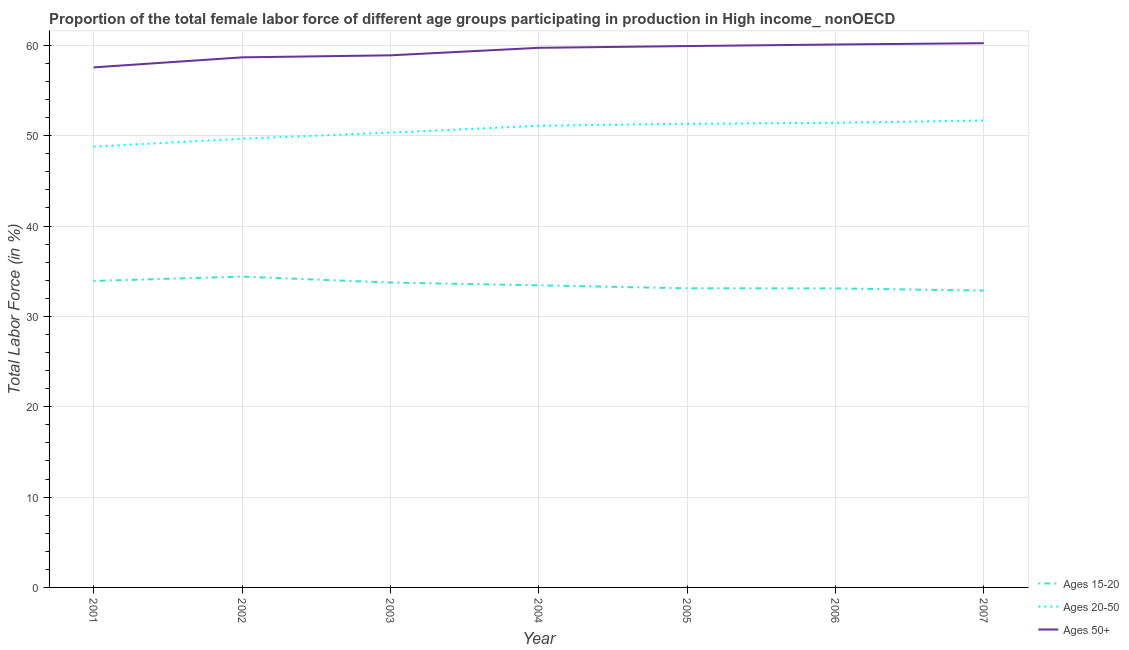How many different coloured lines are there?
Your answer should be compact. 3. Is the number of lines equal to the number of legend labels?
Your response must be concise. Yes. What is the percentage of female labor force within the age group 20-50 in 2002?
Ensure brevity in your answer.  49.66. Across all years, what is the maximum percentage of female labor force within the age group 20-50?
Your answer should be very brief. 51.68. Across all years, what is the minimum percentage of female labor force within the age group 15-20?
Offer a very short reply. 32.85. In which year was the percentage of female labor force within the age group 20-50 minimum?
Keep it short and to the point. 2001. What is the total percentage of female labor force above age 50 in the graph?
Offer a terse response. 415.1. What is the difference between the percentage of female labor force above age 50 in 2002 and that in 2006?
Ensure brevity in your answer.  -1.42. What is the difference between the percentage of female labor force within the age group 20-50 in 2002 and the percentage of female labor force within the age group 15-20 in 2003?
Keep it short and to the point. 15.92. What is the average percentage of female labor force within the age group 20-50 per year?
Your answer should be compact. 50.62. In the year 2001, what is the difference between the percentage of female labor force within the age group 15-20 and percentage of female labor force above age 50?
Make the answer very short. -23.64. What is the ratio of the percentage of female labor force within the age group 20-50 in 2002 to that in 2003?
Offer a terse response. 0.99. Is the percentage of female labor force above age 50 in 2006 less than that in 2007?
Offer a terse response. Yes. Is the difference between the percentage of female labor force within the age group 15-20 in 2002 and 2006 greater than the difference between the percentage of female labor force within the age group 20-50 in 2002 and 2006?
Provide a short and direct response. Yes. What is the difference between the highest and the second highest percentage of female labor force within the age group 20-50?
Your answer should be very brief. 0.26. What is the difference between the highest and the lowest percentage of female labor force within the age group 15-20?
Your answer should be compact. 1.55. Is the sum of the percentage of female labor force above age 50 in 2003 and 2005 greater than the maximum percentage of female labor force within the age group 15-20 across all years?
Offer a very short reply. Yes. Is it the case that in every year, the sum of the percentage of female labor force within the age group 15-20 and percentage of female labor force within the age group 20-50 is greater than the percentage of female labor force above age 50?
Your response must be concise. Yes. Is the percentage of female labor force within the age group 15-20 strictly greater than the percentage of female labor force within the age group 20-50 over the years?
Your answer should be very brief. No. How many lines are there?
Ensure brevity in your answer.  3. How many years are there in the graph?
Keep it short and to the point. 7. What is the difference between two consecutive major ticks on the Y-axis?
Your answer should be very brief. 10. Are the values on the major ticks of Y-axis written in scientific E-notation?
Your response must be concise. No. Does the graph contain grids?
Ensure brevity in your answer.  Yes. Where does the legend appear in the graph?
Provide a succinct answer. Bottom right. How many legend labels are there?
Your response must be concise. 3. What is the title of the graph?
Offer a very short reply. Proportion of the total female labor force of different age groups participating in production in High income_ nonOECD. Does "Domestic economy" appear as one of the legend labels in the graph?
Give a very brief answer. No. What is the label or title of the Y-axis?
Keep it short and to the point. Total Labor Force (in %). What is the Total Labor Force (in %) in Ages 15-20 in 2001?
Your answer should be very brief. 33.92. What is the Total Labor Force (in %) of Ages 20-50 in 2001?
Give a very brief answer. 48.79. What is the Total Labor Force (in %) in Ages 50+ in 2001?
Offer a terse response. 57.56. What is the Total Labor Force (in %) in Ages 15-20 in 2002?
Ensure brevity in your answer.  34.4. What is the Total Labor Force (in %) in Ages 20-50 in 2002?
Provide a short and direct response. 49.66. What is the Total Labor Force (in %) in Ages 50+ in 2002?
Ensure brevity in your answer.  58.67. What is the Total Labor Force (in %) of Ages 15-20 in 2003?
Give a very brief answer. 33.74. What is the Total Labor Force (in %) of Ages 20-50 in 2003?
Your response must be concise. 50.34. What is the Total Labor Force (in %) of Ages 50+ in 2003?
Your response must be concise. 58.89. What is the Total Labor Force (in %) of Ages 15-20 in 2004?
Give a very brief answer. 33.44. What is the Total Labor Force (in %) of Ages 20-50 in 2004?
Keep it short and to the point. 51.1. What is the Total Labor Force (in %) in Ages 50+ in 2004?
Make the answer very short. 59.72. What is the Total Labor Force (in %) of Ages 15-20 in 2005?
Provide a short and direct response. 33.11. What is the Total Labor Force (in %) of Ages 20-50 in 2005?
Provide a short and direct response. 51.32. What is the Total Labor Force (in %) of Ages 50+ in 2005?
Provide a succinct answer. 59.92. What is the Total Labor Force (in %) of Ages 15-20 in 2006?
Keep it short and to the point. 33.1. What is the Total Labor Force (in %) of Ages 20-50 in 2006?
Make the answer very short. 51.42. What is the Total Labor Force (in %) in Ages 50+ in 2006?
Your answer should be very brief. 60.09. What is the Total Labor Force (in %) of Ages 15-20 in 2007?
Make the answer very short. 32.85. What is the Total Labor Force (in %) of Ages 20-50 in 2007?
Provide a succinct answer. 51.68. What is the Total Labor Force (in %) in Ages 50+ in 2007?
Your response must be concise. 60.24. Across all years, what is the maximum Total Labor Force (in %) of Ages 15-20?
Offer a very short reply. 34.4. Across all years, what is the maximum Total Labor Force (in %) in Ages 20-50?
Provide a succinct answer. 51.68. Across all years, what is the maximum Total Labor Force (in %) of Ages 50+?
Give a very brief answer. 60.24. Across all years, what is the minimum Total Labor Force (in %) of Ages 15-20?
Offer a very short reply. 32.85. Across all years, what is the minimum Total Labor Force (in %) of Ages 20-50?
Give a very brief answer. 48.79. Across all years, what is the minimum Total Labor Force (in %) of Ages 50+?
Your answer should be compact. 57.56. What is the total Total Labor Force (in %) in Ages 15-20 in the graph?
Provide a short and direct response. 234.56. What is the total Total Labor Force (in %) in Ages 20-50 in the graph?
Provide a short and direct response. 354.31. What is the total Total Labor Force (in %) of Ages 50+ in the graph?
Make the answer very short. 415.1. What is the difference between the Total Labor Force (in %) in Ages 15-20 in 2001 and that in 2002?
Your response must be concise. -0.48. What is the difference between the Total Labor Force (in %) in Ages 20-50 in 2001 and that in 2002?
Provide a succinct answer. -0.87. What is the difference between the Total Labor Force (in %) in Ages 50+ in 2001 and that in 2002?
Offer a very short reply. -1.11. What is the difference between the Total Labor Force (in %) of Ages 15-20 in 2001 and that in 2003?
Make the answer very short. 0.18. What is the difference between the Total Labor Force (in %) of Ages 20-50 in 2001 and that in 2003?
Your answer should be very brief. -1.55. What is the difference between the Total Labor Force (in %) of Ages 50+ in 2001 and that in 2003?
Your answer should be compact. -1.33. What is the difference between the Total Labor Force (in %) in Ages 15-20 in 2001 and that in 2004?
Your answer should be compact. 0.48. What is the difference between the Total Labor Force (in %) of Ages 20-50 in 2001 and that in 2004?
Your answer should be compact. -2.31. What is the difference between the Total Labor Force (in %) of Ages 50+ in 2001 and that in 2004?
Your answer should be compact. -2.16. What is the difference between the Total Labor Force (in %) in Ages 15-20 in 2001 and that in 2005?
Ensure brevity in your answer.  0.81. What is the difference between the Total Labor Force (in %) in Ages 20-50 in 2001 and that in 2005?
Offer a very short reply. -2.53. What is the difference between the Total Labor Force (in %) in Ages 50+ in 2001 and that in 2005?
Offer a very short reply. -2.36. What is the difference between the Total Labor Force (in %) in Ages 15-20 in 2001 and that in 2006?
Your answer should be compact. 0.82. What is the difference between the Total Labor Force (in %) in Ages 20-50 in 2001 and that in 2006?
Ensure brevity in your answer.  -2.63. What is the difference between the Total Labor Force (in %) of Ages 50+ in 2001 and that in 2006?
Offer a terse response. -2.53. What is the difference between the Total Labor Force (in %) in Ages 15-20 in 2001 and that in 2007?
Give a very brief answer. 1.07. What is the difference between the Total Labor Force (in %) of Ages 20-50 in 2001 and that in 2007?
Ensure brevity in your answer.  -2.89. What is the difference between the Total Labor Force (in %) in Ages 50+ in 2001 and that in 2007?
Offer a terse response. -2.68. What is the difference between the Total Labor Force (in %) in Ages 15-20 in 2002 and that in 2003?
Provide a succinct answer. 0.66. What is the difference between the Total Labor Force (in %) in Ages 20-50 in 2002 and that in 2003?
Offer a very short reply. -0.67. What is the difference between the Total Labor Force (in %) in Ages 50+ in 2002 and that in 2003?
Keep it short and to the point. -0.22. What is the difference between the Total Labor Force (in %) in Ages 15-20 in 2002 and that in 2004?
Provide a succinct answer. 0.96. What is the difference between the Total Labor Force (in %) of Ages 20-50 in 2002 and that in 2004?
Your response must be concise. -1.43. What is the difference between the Total Labor Force (in %) of Ages 50+ in 2002 and that in 2004?
Keep it short and to the point. -1.05. What is the difference between the Total Labor Force (in %) in Ages 15-20 in 2002 and that in 2005?
Offer a very short reply. 1.3. What is the difference between the Total Labor Force (in %) of Ages 20-50 in 2002 and that in 2005?
Offer a terse response. -1.66. What is the difference between the Total Labor Force (in %) in Ages 50+ in 2002 and that in 2005?
Provide a succinct answer. -1.25. What is the difference between the Total Labor Force (in %) in Ages 15-20 in 2002 and that in 2006?
Make the answer very short. 1.3. What is the difference between the Total Labor Force (in %) in Ages 20-50 in 2002 and that in 2006?
Your answer should be compact. -1.76. What is the difference between the Total Labor Force (in %) in Ages 50+ in 2002 and that in 2006?
Keep it short and to the point. -1.42. What is the difference between the Total Labor Force (in %) in Ages 15-20 in 2002 and that in 2007?
Offer a very short reply. 1.55. What is the difference between the Total Labor Force (in %) in Ages 20-50 in 2002 and that in 2007?
Your answer should be compact. -2.02. What is the difference between the Total Labor Force (in %) of Ages 50+ in 2002 and that in 2007?
Your response must be concise. -1.57. What is the difference between the Total Labor Force (in %) of Ages 15-20 in 2003 and that in 2004?
Your response must be concise. 0.3. What is the difference between the Total Labor Force (in %) of Ages 20-50 in 2003 and that in 2004?
Keep it short and to the point. -0.76. What is the difference between the Total Labor Force (in %) of Ages 50+ in 2003 and that in 2004?
Offer a terse response. -0.83. What is the difference between the Total Labor Force (in %) in Ages 15-20 in 2003 and that in 2005?
Your answer should be compact. 0.64. What is the difference between the Total Labor Force (in %) of Ages 20-50 in 2003 and that in 2005?
Provide a succinct answer. -0.98. What is the difference between the Total Labor Force (in %) in Ages 50+ in 2003 and that in 2005?
Give a very brief answer. -1.03. What is the difference between the Total Labor Force (in %) of Ages 15-20 in 2003 and that in 2006?
Offer a terse response. 0.64. What is the difference between the Total Labor Force (in %) of Ages 20-50 in 2003 and that in 2006?
Offer a terse response. -1.09. What is the difference between the Total Labor Force (in %) of Ages 50+ in 2003 and that in 2006?
Give a very brief answer. -1.2. What is the difference between the Total Labor Force (in %) of Ages 15-20 in 2003 and that in 2007?
Your response must be concise. 0.89. What is the difference between the Total Labor Force (in %) in Ages 20-50 in 2003 and that in 2007?
Your answer should be compact. -1.34. What is the difference between the Total Labor Force (in %) of Ages 50+ in 2003 and that in 2007?
Ensure brevity in your answer.  -1.34. What is the difference between the Total Labor Force (in %) in Ages 15-20 in 2004 and that in 2005?
Your answer should be compact. 0.33. What is the difference between the Total Labor Force (in %) in Ages 20-50 in 2004 and that in 2005?
Your answer should be very brief. -0.22. What is the difference between the Total Labor Force (in %) of Ages 50+ in 2004 and that in 2005?
Offer a terse response. -0.19. What is the difference between the Total Labor Force (in %) in Ages 15-20 in 2004 and that in 2006?
Provide a succinct answer. 0.34. What is the difference between the Total Labor Force (in %) of Ages 20-50 in 2004 and that in 2006?
Make the answer very short. -0.33. What is the difference between the Total Labor Force (in %) of Ages 50+ in 2004 and that in 2006?
Ensure brevity in your answer.  -0.37. What is the difference between the Total Labor Force (in %) of Ages 15-20 in 2004 and that in 2007?
Ensure brevity in your answer.  0.59. What is the difference between the Total Labor Force (in %) of Ages 20-50 in 2004 and that in 2007?
Offer a terse response. -0.58. What is the difference between the Total Labor Force (in %) of Ages 50+ in 2004 and that in 2007?
Give a very brief answer. -0.51. What is the difference between the Total Labor Force (in %) in Ages 15-20 in 2005 and that in 2006?
Provide a short and direct response. 0.01. What is the difference between the Total Labor Force (in %) in Ages 20-50 in 2005 and that in 2006?
Make the answer very short. -0.1. What is the difference between the Total Labor Force (in %) of Ages 50+ in 2005 and that in 2006?
Provide a succinct answer. -0.17. What is the difference between the Total Labor Force (in %) of Ages 15-20 in 2005 and that in 2007?
Give a very brief answer. 0.25. What is the difference between the Total Labor Force (in %) of Ages 20-50 in 2005 and that in 2007?
Your answer should be very brief. -0.36. What is the difference between the Total Labor Force (in %) of Ages 50+ in 2005 and that in 2007?
Your answer should be compact. -0.32. What is the difference between the Total Labor Force (in %) of Ages 15-20 in 2006 and that in 2007?
Keep it short and to the point. 0.24. What is the difference between the Total Labor Force (in %) of Ages 20-50 in 2006 and that in 2007?
Your answer should be very brief. -0.26. What is the difference between the Total Labor Force (in %) in Ages 50+ in 2006 and that in 2007?
Your answer should be compact. -0.14. What is the difference between the Total Labor Force (in %) of Ages 15-20 in 2001 and the Total Labor Force (in %) of Ages 20-50 in 2002?
Your answer should be very brief. -15.74. What is the difference between the Total Labor Force (in %) of Ages 15-20 in 2001 and the Total Labor Force (in %) of Ages 50+ in 2002?
Provide a succinct answer. -24.75. What is the difference between the Total Labor Force (in %) in Ages 20-50 in 2001 and the Total Labor Force (in %) in Ages 50+ in 2002?
Provide a succinct answer. -9.88. What is the difference between the Total Labor Force (in %) of Ages 15-20 in 2001 and the Total Labor Force (in %) of Ages 20-50 in 2003?
Offer a terse response. -16.42. What is the difference between the Total Labor Force (in %) in Ages 15-20 in 2001 and the Total Labor Force (in %) in Ages 50+ in 2003?
Provide a succinct answer. -24.97. What is the difference between the Total Labor Force (in %) in Ages 20-50 in 2001 and the Total Labor Force (in %) in Ages 50+ in 2003?
Ensure brevity in your answer.  -10.1. What is the difference between the Total Labor Force (in %) in Ages 15-20 in 2001 and the Total Labor Force (in %) in Ages 20-50 in 2004?
Give a very brief answer. -17.18. What is the difference between the Total Labor Force (in %) in Ages 15-20 in 2001 and the Total Labor Force (in %) in Ages 50+ in 2004?
Offer a very short reply. -25.81. What is the difference between the Total Labor Force (in %) in Ages 20-50 in 2001 and the Total Labor Force (in %) in Ages 50+ in 2004?
Provide a succinct answer. -10.94. What is the difference between the Total Labor Force (in %) in Ages 15-20 in 2001 and the Total Labor Force (in %) in Ages 20-50 in 2005?
Offer a terse response. -17.4. What is the difference between the Total Labor Force (in %) of Ages 15-20 in 2001 and the Total Labor Force (in %) of Ages 50+ in 2005?
Offer a very short reply. -26. What is the difference between the Total Labor Force (in %) in Ages 20-50 in 2001 and the Total Labor Force (in %) in Ages 50+ in 2005?
Provide a short and direct response. -11.13. What is the difference between the Total Labor Force (in %) of Ages 15-20 in 2001 and the Total Labor Force (in %) of Ages 20-50 in 2006?
Your response must be concise. -17.5. What is the difference between the Total Labor Force (in %) in Ages 15-20 in 2001 and the Total Labor Force (in %) in Ages 50+ in 2006?
Give a very brief answer. -26.17. What is the difference between the Total Labor Force (in %) in Ages 20-50 in 2001 and the Total Labor Force (in %) in Ages 50+ in 2006?
Offer a very short reply. -11.3. What is the difference between the Total Labor Force (in %) in Ages 15-20 in 2001 and the Total Labor Force (in %) in Ages 20-50 in 2007?
Keep it short and to the point. -17.76. What is the difference between the Total Labor Force (in %) in Ages 15-20 in 2001 and the Total Labor Force (in %) in Ages 50+ in 2007?
Give a very brief answer. -26.32. What is the difference between the Total Labor Force (in %) in Ages 20-50 in 2001 and the Total Labor Force (in %) in Ages 50+ in 2007?
Your response must be concise. -11.45. What is the difference between the Total Labor Force (in %) in Ages 15-20 in 2002 and the Total Labor Force (in %) in Ages 20-50 in 2003?
Ensure brevity in your answer.  -15.93. What is the difference between the Total Labor Force (in %) of Ages 15-20 in 2002 and the Total Labor Force (in %) of Ages 50+ in 2003?
Provide a short and direct response. -24.49. What is the difference between the Total Labor Force (in %) of Ages 20-50 in 2002 and the Total Labor Force (in %) of Ages 50+ in 2003?
Offer a terse response. -9.23. What is the difference between the Total Labor Force (in %) of Ages 15-20 in 2002 and the Total Labor Force (in %) of Ages 20-50 in 2004?
Provide a succinct answer. -16.69. What is the difference between the Total Labor Force (in %) in Ages 15-20 in 2002 and the Total Labor Force (in %) in Ages 50+ in 2004?
Offer a very short reply. -25.32. What is the difference between the Total Labor Force (in %) in Ages 20-50 in 2002 and the Total Labor Force (in %) in Ages 50+ in 2004?
Provide a succinct answer. -10.06. What is the difference between the Total Labor Force (in %) of Ages 15-20 in 2002 and the Total Labor Force (in %) of Ages 20-50 in 2005?
Your response must be concise. -16.92. What is the difference between the Total Labor Force (in %) in Ages 15-20 in 2002 and the Total Labor Force (in %) in Ages 50+ in 2005?
Your answer should be compact. -25.52. What is the difference between the Total Labor Force (in %) in Ages 20-50 in 2002 and the Total Labor Force (in %) in Ages 50+ in 2005?
Offer a terse response. -10.26. What is the difference between the Total Labor Force (in %) in Ages 15-20 in 2002 and the Total Labor Force (in %) in Ages 20-50 in 2006?
Your answer should be compact. -17.02. What is the difference between the Total Labor Force (in %) of Ages 15-20 in 2002 and the Total Labor Force (in %) of Ages 50+ in 2006?
Provide a short and direct response. -25.69. What is the difference between the Total Labor Force (in %) in Ages 20-50 in 2002 and the Total Labor Force (in %) in Ages 50+ in 2006?
Give a very brief answer. -10.43. What is the difference between the Total Labor Force (in %) in Ages 15-20 in 2002 and the Total Labor Force (in %) in Ages 20-50 in 2007?
Ensure brevity in your answer.  -17.28. What is the difference between the Total Labor Force (in %) of Ages 15-20 in 2002 and the Total Labor Force (in %) of Ages 50+ in 2007?
Provide a succinct answer. -25.83. What is the difference between the Total Labor Force (in %) in Ages 20-50 in 2002 and the Total Labor Force (in %) in Ages 50+ in 2007?
Your answer should be compact. -10.57. What is the difference between the Total Labor Force (in %) of Ages 15-20 in 2003 and the Total Labor Force (in %) of Ages 20-50 in 2004?
Your response must be concise. -17.35. What is the difference between the Total Labor Force (in %) of Ages 15-20 in 2003 and the Total Labor Force (in %) of Ages 50+ in 2004?
Provide a short and direct response. -25.98. What is the difference between the Total Labor Force (in %) of Ages 20-50 in 2003 and the Total Labor Force (in %) of Ages 50+ in 2004?
Make the answer very short. -9.39. What is the difference between the Total Labor Force (in %) in Ages 15-20 in 2003 and the Total Labor Force (in %) in Ages 20-50 in 2005?
Offer a very short reply. -17.58. What is the difference between the Total Labor Force (in %) of Ages 15-20 in 2003 and the Total Labor Force (in %) of Ages 50+ in 2005?
Provide a short and direct response. -26.18. What is the difference between the Total Labor Force (in %) of Ages 20-50 in 2003 and the Total Labor Force (in %) of Ages 50+ in 2005?
Keep it short and to the point. -9.58. What is the difference between the Total Labor Force (in %) of Ages 15-20 in 2003 and the Total Labor Force (in %) of Ages 20-50 in 2006?
Give a very brief answer. -17.68. What is the difference between the Total Labor Force (in %) of Ages 15-20 in 2003 and the Total Labor Force (in %) of Ages 50+ in 2006?
Give a very brief answer. -26.35. What is the difference between the Total Labor Force (in %) of Ages 20-50 in 2003 and the Total Labor Force (in %) of Ages 50+ in 2006?
Give a very brief answer. -9.76. What is the difference between the Total Labor Force (in %) in Ages 15-20 in 2003 and the Total Labor Force (in %) in Ages 20-50 in 2007?
Give a very brief answer. -17.94. What is the difference between the Total Labor Force (in %) of Ages 15-20 in 2003 and the Total Labor Force (in %) of Ages 50+ in 2007?
Provide a succinct answer. -26.49. What is the difference between the Total Labor Force (in %) of Ages 20-50 in 2003 and the Total Labor Force (in %) of Ages 50+ in 2007?
Ensure brevity in your answer.  -9.9. What is the difference between the Total Labor Force (in %) in Ages 15-20 in 2004 and the Total Labor Force (in %) in Ages 20-50 in 2005?
Your answer should be compact. -17.88. What is the difference between the Total Labor Force (in %) in Ages 15-20 in 2004 and the Total Labor Force (in %) in Ages 50+ in 2005?
Your answer should be very brief. -26.48. What is the difference between the Total Labor Force (in %) in Ages 20-50 in 2004 and the Total Labor Force (in %) in Ages 50+ in 2005?
Give a very brief answer. -8.82. What is the difference between the Total Labor Force (in %) in Ages 15-20 in 2004 and the Total Labor Force (in %) in Ages 20-50 in 2006?
Offer a terse response. -17.98. What is the difference between the Total Labor Force (in %) of Ages 15-20 in 2004 and the Total Labor Force (in %) of Ages 50+ in 2006?
Your answer should be compact. -26.65. What is the difference between the Total Labor Force (in %) in Ages 20-50 in 2004 and the Total Labor Force (in %) in Ages 50+ in 2006?
Give a very brief answer. -9. What is the difference between the Total Labor Force (in %) of Ages 15-20 in 2004 and the Total Labor Force (in %) of Ages 20-50 in 2007?
Keep it short and to the point. -18.24. What is the difference between the Total Labor Force (in %) of Ages 15-20 in 2004 and the Total Labor Force (in %) of Ages 50+ in 2007?
Provide a succinct answer. -26.8. What is the difference between the Total Labor Force (in %) of Ages 20-50 in 2004 and the Total Labor Force (in %) of Ages 50+ in 2007?
Offer a very short reply. -9.14. What is the difference between the Total Labor Force (in %) in Ages 15-20 in 2005 and the Total Labor Force (in %) in Ages 20-50 in 2006?
Offer a very short reply. -18.32. What is the difference between the Total Labor Force (in %) of Ages 15-20 in 2005 and the Total Labor Force (in %) of Ages 50+ in 2006?
Make the answer very short. -26.99. What is the difference between the Total Labor Force (in %) of Ages 20-50 in 2005 and the Total Labor Force (in %) of Ages 50+ in 2006?
Your response must be concise. -8.77. What is the difference between the Total Labor Force (in %) in Ages 15-20 in 2005 and the Total Labor Force (in %) in Ages 20-50 in 2007?
Provide a short and direct response. -18.57. What is the difference between the Total Labor Force (in %) of Ages 15-20 in 2005 and the Total Labor Force (in %) of Ages 50+ in 2007?
Offer a very short reply. -27.13. What is the difference between the Total Labor Force (in %) in Ages 20-50 in 2005 and the Total Labor Force (in %) in Ages 50+ in 2007?
Your response must be concise. -8.92. What is the difference between the Total Labor Force (in %) in Ages 15-20 in 2006 and the Total Labor Force (in %) in Ages 20-50 in 2007?
Keep it short and to the point. -18.58. What is the difference between the Total Labor Force (in %) of Ages 15-20 in 2006 and the Total Labor Force (in %) of Ages 50+ in 2007?
Give a very brief answer. -27.14. What is the difference between the Total Labor Force (in %) of Ages 20-50 in 2006 and the Total Labor Force (in %) of Ages 50+ in 2007?
Your answer should be compact. -8.81. What is the average Total Labor Force (in %) in Ages 15-20 per year?
Your response must be concise. 33.51. What is the average Total Labor Force (in %) in Ages 20-50 per year?
Offer a very short reply. 50.62. What is the average Total Labor Force (in %) in Ages 50+ per year?
Provide a short and direct response. 59.3. In the year 2001, what is the difference between the Total Labor Force (in %) in Ages 15-20 and Total Labor Force (in %) in Ages 20-50?
Keep it short and to the point. -14.87. In the year 2001, what is the difference between the Total Labor Force (in %) of Ages 15-20 and Total Labor Force (in %) of Ages 50+?
Offer a very short reply. -23.64. In the year 2001, what is the difference between the Total Labor Force (in %) in Ages 20-50 and Total Labor Force (in %) in Ages 50+?
Offer a terse response. -8.77. In the year 2002, what is the difference between the Total Labor Force (in %) in Ages 15-20 and Total Labor Force (in %) in Ages 20-50?
Provide a short and direct response. -15.26. In the year 2002, what is the difference between the Total Labor Force (in %) in Ages 15-20 and Total Labor Force (in %) in Ages 50+?
Your response must be concise. -24.27. In the year 2002, what is the difference between the Total Labor Force (in %) in Ages 20-50 and Total Labor Force (in %) in Ages 50+?
Provide a succinct answer. -9.01. In the year 2003, what is the difference between the Total Labor Force (in %) of Ages 15-20 and Total Labor Force (in %) of Ages 20-50?
Offer a very short reply. -16.59. In the year 2003, what is the difference between the Total Labor Force (in %) of Ages 15-20 and Total Labor Force (in %) of Ages 50+?
Ensure brevity in your answer.  -25.15. In the year 2003, what is the difference between the Total Labor Force (in %) of Ages 20-50 and Total Labor Force (in %) of Ages 50+?
Make the answer very short. -8.56. In the year 2004, what is the difference between the Total Labor Force (in %) in Ages 15-20 and Total Labor Force (in %) in Ages 20-50?
Provide a succinct answer. -17.66. In the year 2004, what is the difference between the Total Labor Force (in %) in Ages 15-20 and Total Labor Force (in %) in Ages 50+?
Provide a short and direct response. -26.28. In the year 2004, what is the difference between the Total Labor Force (in %) of Ages 20-50 and Total Labor Force (in %) of Ages 50+?
Your answer should be compact. -8.63. In the year 2005, what is the difference between the Total Labor Force (in %) of Ages 15-20 and Total Labor Force (in %) of Ages 20-50?
Your response must be concise. -18.21. In the year 2005, what is the difference between the Total Labor Force (in %) of Ages 15-20 and Total Labor Force (in %) of Ages 50+?
Make the answer very short. -26.81. In the year 2005, what is the difference between the Total Labor Force (in %) in Ages 20-50 and Total Labor Force (in %) in Ages 50+?
Your answer should be very brief. -8.6. In the year 2006, what is the difference between the Total Labor Force (in %) in Ages 15-20 and Total Labor Force (in %) in Ages 20-50?
Offer a very short reply. -18.33. In the year 2006, what is the difference between the Total Labor Force (in %) of Ages 15-20 and Total Labor Force (in %) of Ages 50+?
Offer a terse response. -26.99. In the year 2006, what is the difference between the Total Labor Force (in %) of Ages 20-50 and Total Labor Force (in %) of Ages 50+?
Keep it short and to the point. -8.67. In the year 2007, what is the difference between the Total Labor Force (in %) of Ages 15-20 and Total Labor Force (in %) of Ages 20-50?
Ensure brevity in your answer.  -18.83. In the year 2007, what is the difference between the Total Labor Force (in %) in Ages 15-20 and Total Labor Force (in %) in Ages 50+?
Give a very brief answer. -27.38. In the year 2007, what is the difference between the Total Labor Force (in %) in Ages 20-50 and Total Labor Force (in %) in Ages 50+?
Provide a succinct answer. -8.56. What is the ratio of the Total Labor Force (in %) of Ages 15-20 in 2001 to that in 2002?
Your answer should be compact. 0.99. What is the ratio of the Total Labor Force (in %) of Ages 20-50 in 2001 to that in 2002?
Offer a terse response. 0.98. What is the ratio of the Total Labor Force (in %) of Ages 50+ in 2001 to that in 2002?
Make the answer very short. 0.98. What is the ratio of the Total Labor Force (in %) of Ages 15-20 in 2001 to that in 2003?
Ensure brevity in your answer.  1.01. What is the ratio of the Total Labor Force (in %) in Ages 20-50 in 2001 to that in 2003?
Provide a short and direct response. 0.97. What is the ratio of the Total Labor Force (in %) in Ages 50+ in 2001 to that in 2003?
Make the answer very short. 0.98. What is the ratio of the Total Labor Force (in %) in Ages 15-20 in 2001 to that in 2004?
Offer a very short reply. 1.01. What is the ratio of the Total Labor Force (in %) in Ages 20-50 in 2001 to that in 2004?
Your answer should be compact. 0.95. What is the ratio of the Total Labor Force (in %) in Ages 50+ in 2001 to that in 2004?
Give a very brief answer. 0.96. What is the ratio of the Total Labor Force (in %) of Ages 15-20 in 2001 to that in 2005?
Offer a very short reply. 1.02. What is the ratio of the Total Labor Force (in %) of Ages 20-50 in 2001 to that in 2005?
Ensure brevity in your answer.  0.95. What is the ratio of the Total Labor Force (in %) in Ages 50+ in 2001 to that in 2005?
Make the answer very short. 0.96. What is the ratio of the Total Labor Force (in %) in Ages 15-20 in 2001 to that in 2006?
Give a very brief answer. 1.02. What is the ratio of the Total Labor Force (in %) of Ages 20-50 in 2001 to that in 2006?
Your answer should be compact. 0.95. What is the ratio of the Total Labor Force (in %) in Ages 50+ in 2001 to that in 2006?
Your response must be concise. 0.96. What is the ratio of the Total Labor Force (in %) in Ages 15-20 in 2001 to that in 2007?
Your response must be concise. 1.03. What is the ratio of the Total Labor Force (in %) of Ages 20-50 in 2001 to that in 2007?
Offer a very short reply. 0.94. What is the ratio of the Total Labor Force (in %) of Ages 50+ in 2001 to that in 2007?
Provide a succinct answer. 0.96. What is the ratio of the Total Labor Force (in %) in Ages 15-20 in 2002 to that in 2003?
Provide a succinct answer. 1.02. What is the ratio of the Total Labor Force (in %) of Ages 20-50 in 2002 to that in 2003?
Keep it short and to the point. 0.99. What is the ratio of the Total Labor Force (in %) in Ages 15-20 in 2002 to that in 2004?
Make the answer very short. 1.03. What is the ratio of the Total Labor Force (in %) in Ages 20-50 in 2002 to that in 2004?
Your answer should be compact. 0.97. What is the ratio of the Total Labor Force (in %) in Ages 50+ in 2002 to that in 2004?
Provide a succinct answer. 0.98. What is the ratio of the Total Labor Force (in %) of Ages 15-20 in 2002 to that in 2005?
Give a very brief answer. 1.04. What is the ratio of the Total Labor Force (in %) in Ages 50+ in 2002 to that in 2005?
Ensure brevity in your answer.  0.98. What is the ratio of the Total Labor Force (in %) in Ages 15-20 in 2002 to that in 2006?
Give a very brief answer. 1.04. What is the ratio of the Total Labor Force (in %) in Ages 20-50 in 2002 to that in 2006?
Offer a terse response. 0.97. What is the ratio of the Total Labor Force (in %) of Ages 50+ in 2002 to that in 2006?
Provide a short and direct response. 0.98. What is the ratio of the Total Labor Force (in %) in Ages 15-20 in 2002 to that in 2007?
Provide a succinct answer. 1.05. What is the ratio of the Total Labor Force (in %) of Ages 50+ in 2002 to that in 2007?
Provide a succinct answer. 0.97. What is the ratio of the Total Labor Force (in %) of Ages 15-20 in 2003 to that in 2004?
Ensure brevity in your answer.  1.01. What is the ratio of the Total Labor Force (in %) of Ages 20-50 in 2003 to that in 2004?
Your answer should be very brief. 0.99. What is the ratio of the Total Labor Force (in %) of Ages 50+ in 2003 to that in 2004?
Ensure brevity in your answer.  0.99. What is the ratio of the Total Labor Force (in %) of Ages 15-20 in 2003 to that in 2005?
Make the answer very short. 1.02. What is the ratio of the Total Labor Force (in %) in Ages 20-50 in 2003 to that in 2005?
Give a very brief answer. 0.98. What is the ratio of the Total Labor Force (in %) in Ages 50+ in 2003 to that in 2005?
Offer a terse response. 0.98. What is the ratio of the Total Labor Force (in %) of Ages 15-20 in 2003 to that in 2006?
Provide a short and direct response. 1.02. What is the ratio of the Total Labor Force (in %) of Ages 20-50 in 2003 to that in 2006?
Make the answer very short. 0.98. What is the ratio of the Total Labor Force (in %) of Ages 50+ in 2003 to that in 2006?
Make the answer very short. 0.98. What is the ratio of the Total Labor Force (in %) of Ages 50+ in 2003 to that in 2007?
Give a very brief answer. 0.98. What is the ratio of the Total Labor Force (in %) in Ages 20-50 in 2004 to that in 2005?
Offer a very short reply. 1. What is the ratio of the Total Labor Force (in %) in Ages 15-20 in 2004 to that in 2006?
Make the answer very short. 1.01. What is the ratio of the Total Labor Force (in %) of Ages 20-50 in 2004 to that in 2006?
Your answer should be compact. 0.99. What is the ratio of the Total Labor Force (in %) in Ages 15-20 in 2004 to that in 2007?
Keep it short and to the point. 1.02. What is the ratio of the Total Labor Force (in %) of Ages 20-50 in 2004 to that in 2007?
Your response must be concise. 0.99. What is the ratio of the Total Labor Force (in %) in Ages 15-20 in 2005 to that in 2007?
Provide a succinct answer. 1.01. What is the ratio of the Total Labor Force (in %) in Ages 50+ in 2005 to that in 2007?
Ensure brevity in your answer.  0.99. What is the ratio of the Total Labor Force (in %) in Ages 15-20 in 2006 to that in 2007?
Keep it short and to the point. 1.01. What is the ratio of the Total Labor Force (in %) of Ages 50+ in 2006 to that in 2007?
Your answer should be compact. 1. What is the difference between the highest and the second highest Total Labor Force (in %) of Ages 15-20?
Ensure brevity in your answer.  0.48. What is the difference between the highest and the second highest Total Labor Force (in %) of Ages 20-50?
Your answer should be compact. 0.26. What is the difference between the highest and the second highest Total Labor Force (in %) of Ages 50+?
Your answer should be very brief. 0.14. What is the difference between the highest and the lowest Total Labor Force (in %) in Ages 15-20?
Your answer should be compact. 1.55. What is the difference between the highest and the lowest Total Labor Force (in %) of Ages 20-50?
Offer a terse response. 2.89. What is the difference between the highest and the lowest Total Labor Force (in %) of Ages 50+?
Provide a succinct answer. 2.68. 